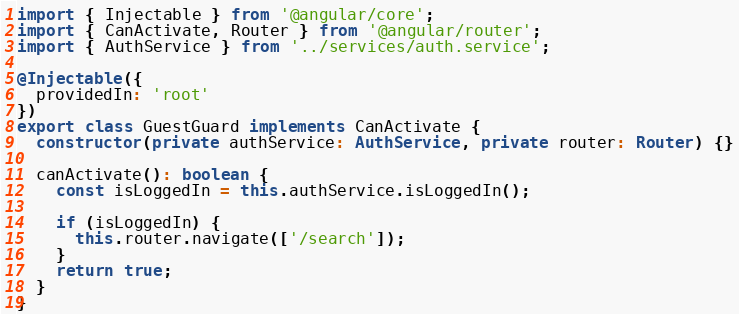<code> <loc_0><loc_0><loc_500><loc_500><_TypeScript_>import { Injectable } from '@angular/core';
import { CanActivate, Router } from '@angular/router';
import { AuthService } from '../services/auth.service';

@Injectable({
  providedIn: 'root'
})
export class GuestGuard implements CanActivate {
  constructor(private authService: AuthService, private router: Router) {}

  canActivate(): boolean {
    const isLoggedIn = this.authService.isLoggedIn();

    if (isLoggedIn) {
      this.router.navigate(['/search']);
    }
    return true;
  }
}
</code> 